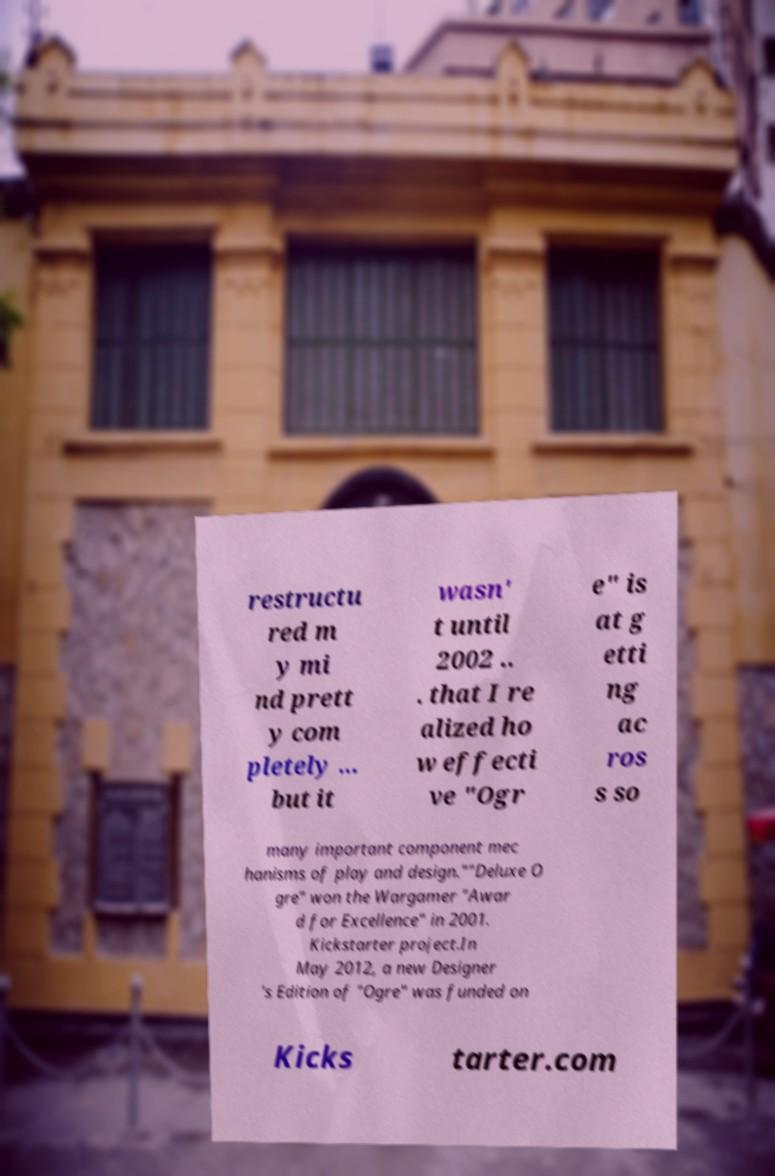Could you extract and type out the text from this image? restructu red m y mi nd prett y com pletely ... but it wasn' t until 2002 .. . that I re alized ho w effecti ve "Ogr e" is at g etti ng ac ros s so many important component mec hanisms of play and design.""Deluxe O gre" won the Wargamer "Awar d for Excellence" in 2001. Kickstarter project.In May 2012, a new Designer 's Edition of "Ogre" was funded on Kicks tarter.com 